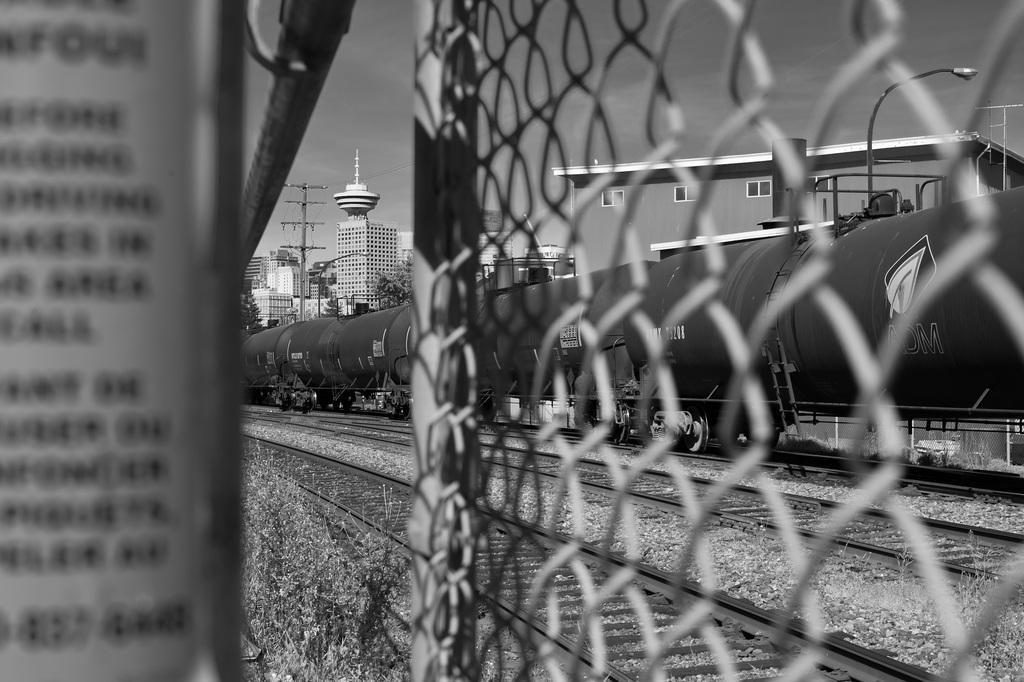What is present on the right side of the image? There is a train on the tracks on the right side of the image. What can be seen in the background of the image? There are buildings, trees, and poles in the background of the image. What type of structure is visible in the image? There is a fence in the image. What type of furniture can be seen in the image? There is no furniture present in the image. Can you describe the bee's activity in the image? There are no bees present in the image. 